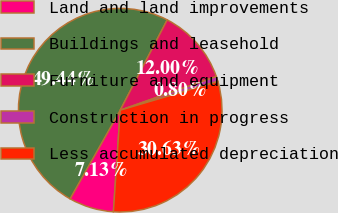Convert chart. <chart><loc_0><loc_0><loc_500><loc_500><pie_chart><fcel>Land and land improvements<fcel>Buildings and leasehold<fcel>Furniture and equipment<fcel>Construction in progress<fcel>Less accumulated depreciation<nl><fcel>7.13%<fcel>49.44%<fcel>12.0%<fcel>0.8%<fcel>30.63%<nl></chart> 